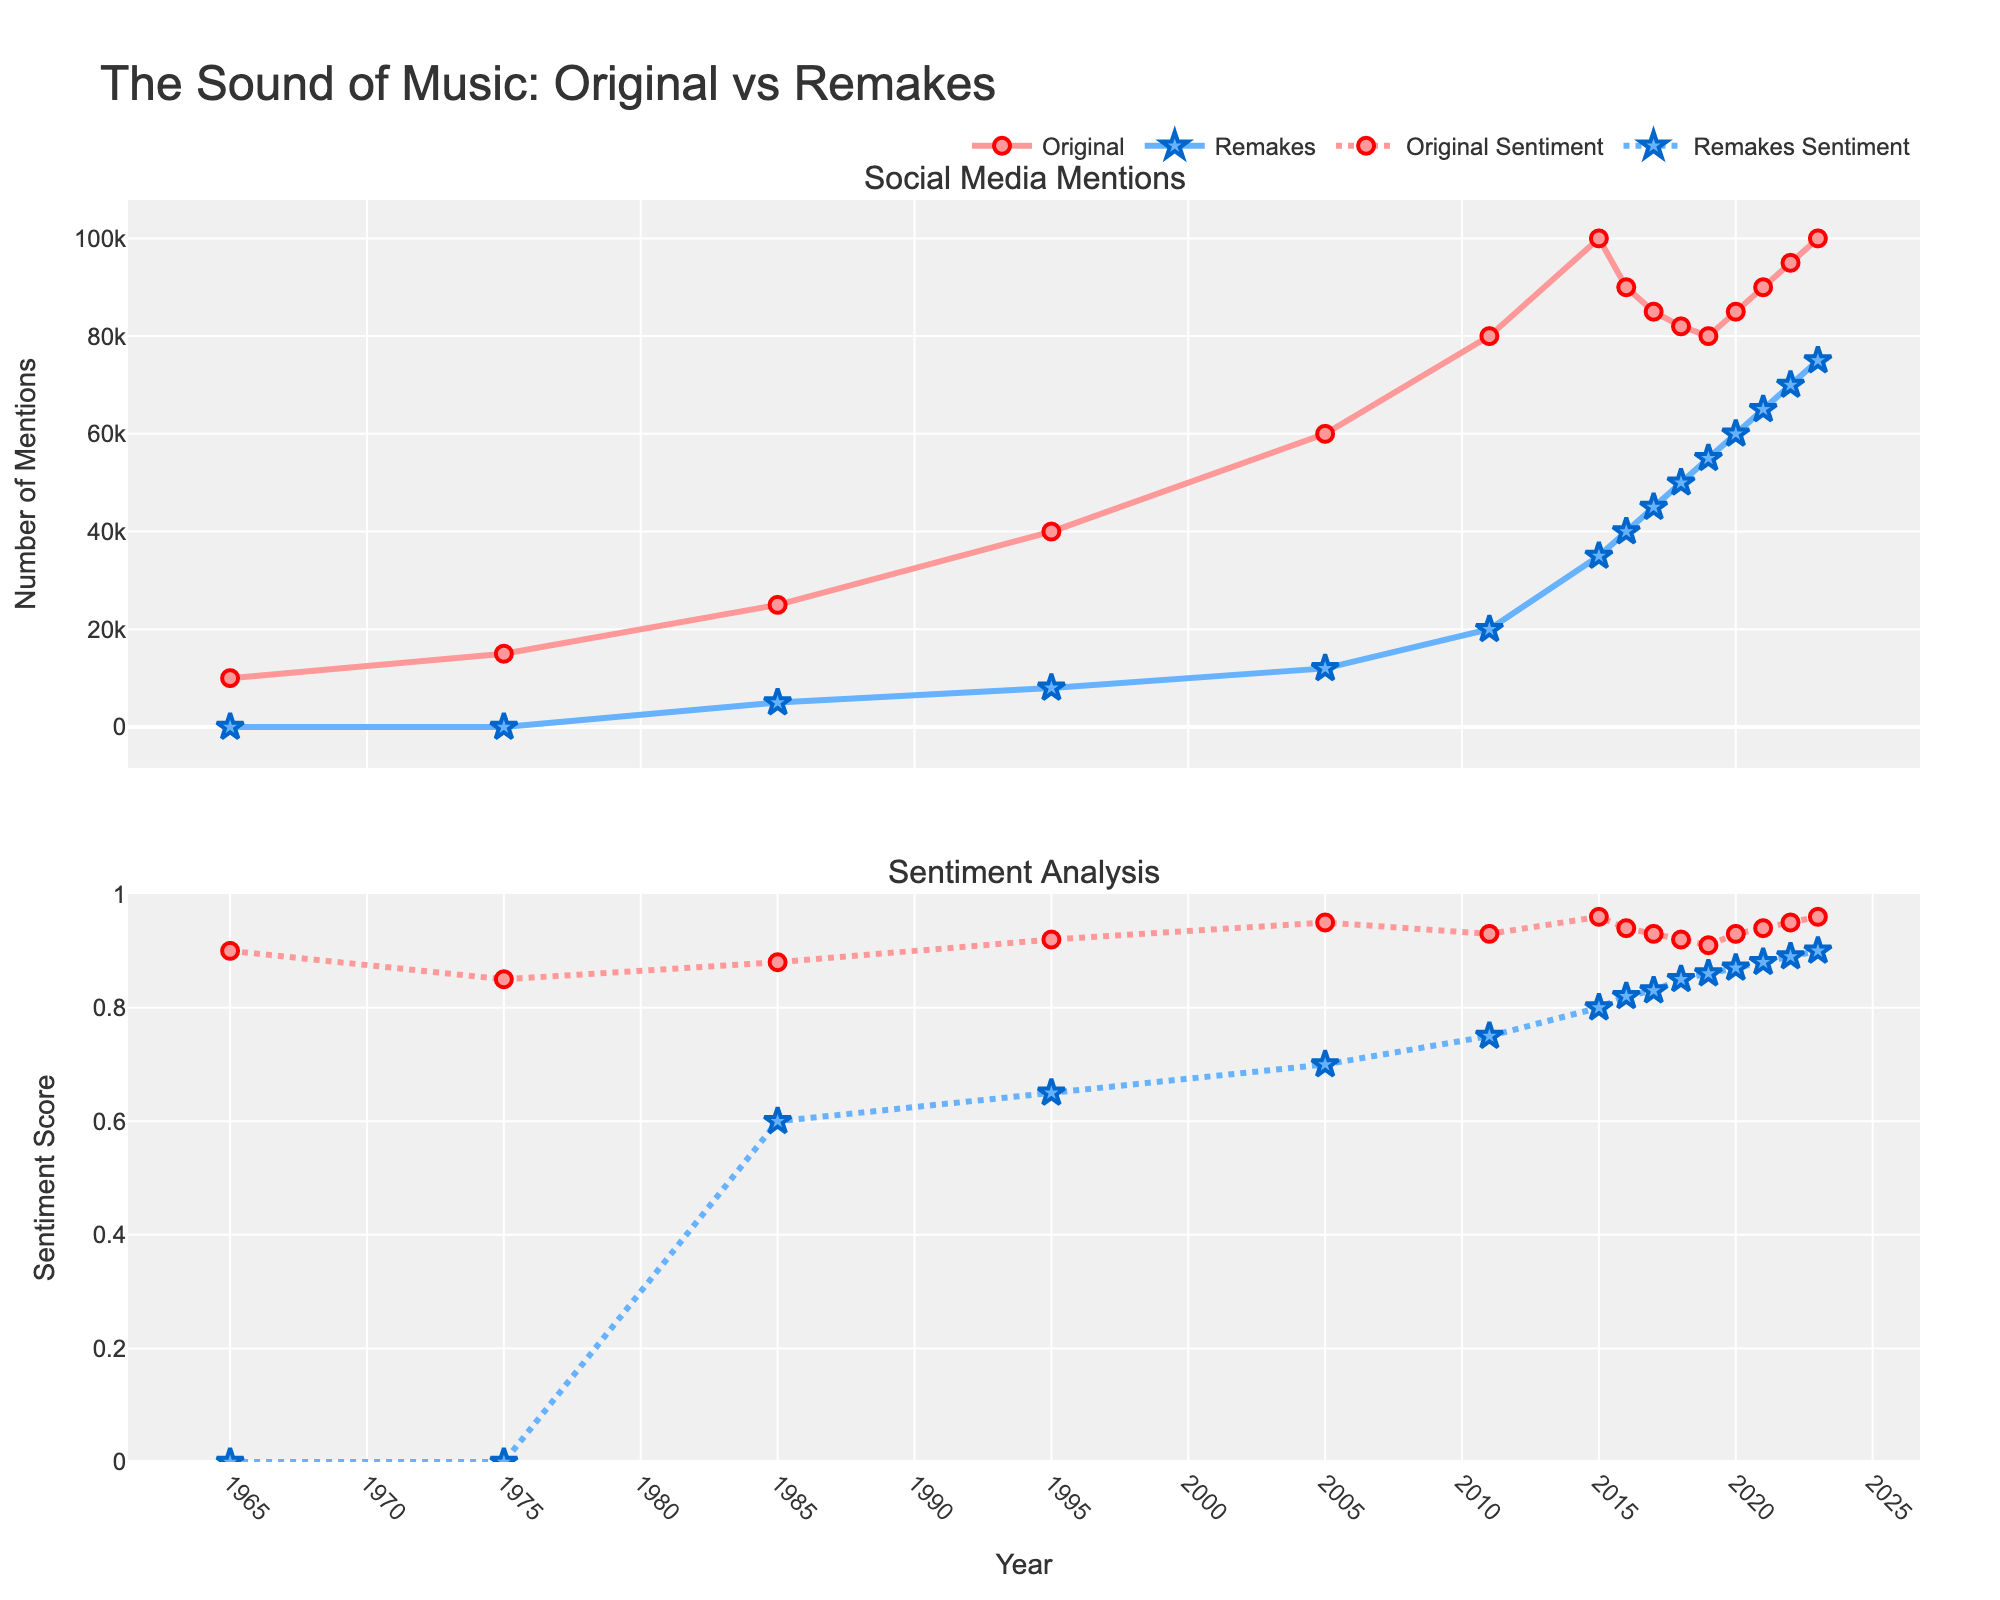How do the mentions of the original compare to the mentions of the remake in 2023? Look at the points in 2023 on the upper plot. The original has 100000 mentions and the remake has 75000 mentions. Therefore, the original had more mentions.
Answer: The original has more mentions What is the average sentiment score for the remakes from 2015 to 2023? Average is calculated by summing the sentiment scores from 2015 to 2023 and dividing by the number of years. Sum = 0.8 + 0.82 + 0.83 + 0.85 + 0.86 + 0.87 + 0.88 + 0.89 + 0.9 = 7.7. Number of years = 9. Average = 7.7 / 9 = 0.855
Answer: 0.855 In which year did the remake first appear in terms of mentions? Look at the first nonzero value for remake mentions on the upper plot. The first mention of remakes appears in 1985.
Answer: 1985 Which year had the highest sentiment score for the original? Find the highest point on the lower plot for the original sentiment line. The highest sentiment score for the original is in 2015 with a score of 0.96.
Answer: 2015 How did the sentiment of the remake change between 2016 and 2017? Compare the points for remake sentiment in 2016 and 2017 on the lower plot. In 2016, the sentiment is 0.82, and in 2017, it is 0.83. Therefore, there was an increase.
Answer: Increase Compare the number of mentions of the original and the remake in 2005. Which one is greater and by how much? Original mentions in 2005 are 60000 and remake mentions are 12000. The difference is 60000 - 12000 = 48000. The original has more mentions by 48000.
Answer: Original by 48000 What was the sentiment score of the remakes in 2020, and how does it compare to the original's sentiment that year? Look at the sentiment scores for both the original and the remake in 2020 on the lower plot. The remake sentiment is 0.87 and the original sentiment is 0.93. The original's sentiment is higher.
Answer: Original's sentiment is higher How many more mentions did the original receive in 2011 compared to 1995? Subtract the number of mentions in 1995 from the number of mentions in 2011 for the original. 80000 (2011) - 40000 (1995) = 40000 more mentions.
Answer: 40000 more mentions What trend do you observe in the sentiment scores of the remakes from 2015 to 2023? Look at the sentiment scores for the remakes from 2015 to 2023 on the lower plot. The sentiment scores for the remakes show an upward trend, increasing from 0.8 to 0.9 over this period.
Answer: Upward trend Between 1975 and 1985, which year saw a greater increase in mentions for the original? Look at the points for 1975 and 1985 on the upper plot for original mentions. The increase from 1975 to 1985 is 25000 - 15000 = 10000 mentions. Since we're only comparing between these years, 1985 saw the greater increase.
Answer: 1985 